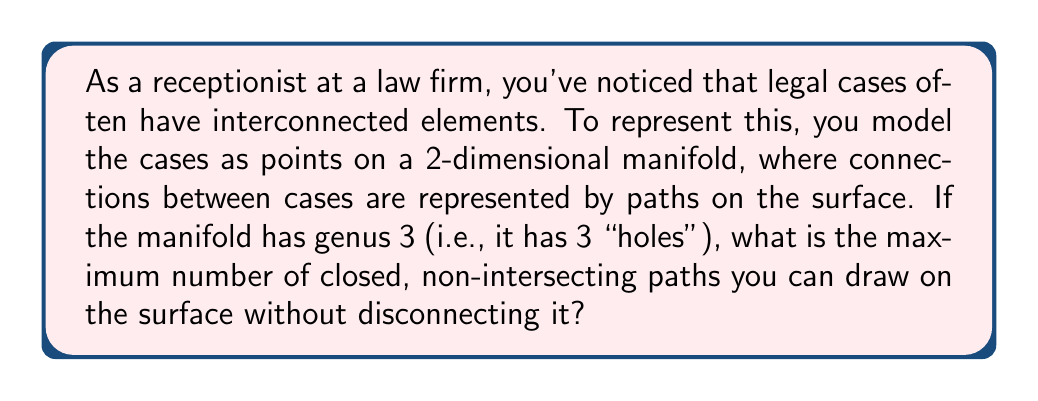Teach me how to tackle this problem. To solve this problem, we need to understand the concept of genus and how it relates to the topology of a manifold. Let's break it down step-by-step:

1) The genus of a surface is the number of "holes" it has. A surface with genus 3 is topologically equivalent to a sphere with 3 handles.

2) In topology, the maximum number of closed, non-intersecting curves that can be drawn on a surface without disconnecting it is related to the genus of the surface. This number is given by the formula:

   $$N = 2g$$

   Where $N$ is the maximum number of curves, and $g$ is the genus of the surface.

3) In this case, we're given that the genus $g = 3$.

4) Substituting this into our formula:

   $$N = 2(3) = 6$$

5) To understand why this is true, consider cutting the surface along these curves. Each cut adds two new edges to the resulting shape. If we were to cut along more than 6 curves, we would disconnect the surface into multiple pieces.

6) In the context of the law firm, this means you could represent up to 6 major themes or connections between cases without losing the overall interconnectedness of the legal landscape.

[asy]
import geometry;

size(200);
path p = circle((0,0),1);
path h1 = circle((0.4,0.4),0.2);
path h2 = circle((-0.4,0.4),0.2);
path h3 = circle((0,-0.4),0.2);

fill(p,lightgrey);
unfill(h1);
unfill(h2);
unfill(h3);

draw(p);
draw(h1);
draw(h2);
draw(h3);

label("Genus 3 surface",(-0.7,1.2));
[/asy]
Answer: The maximum number of closed, non-intersecting paths that can be drawn on the manifold without disconnecting it is 6. 